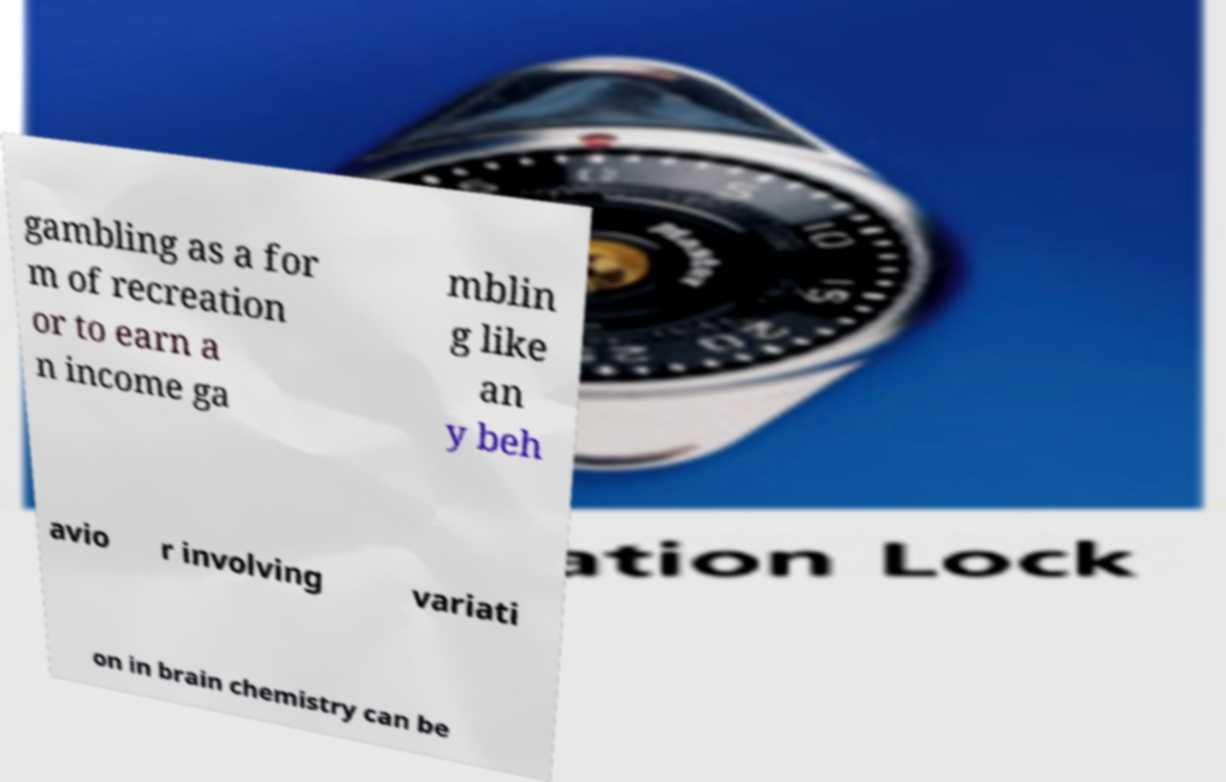I need the written content from this picture converted into text. Can you do that? gambling as a for m of recreation or to earn a n income ga mblin g like an y beh avio r involving variati on in brain chemistry can be 